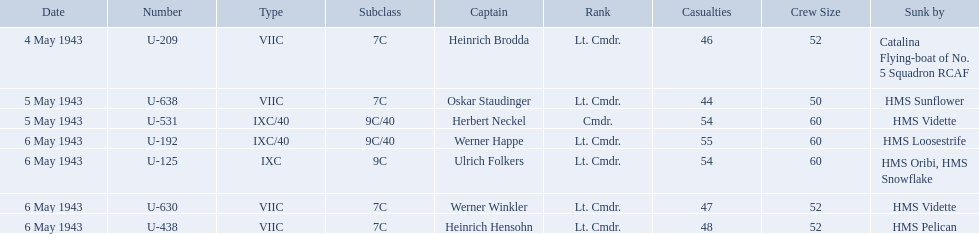Who were the captains in the ons 5 convoy? Heinrich Brodda, Oskar Staudinger, Herbert Neckel, Werner Happe, Ulrich Folkers, Werner Winkler, Heinrich Hensohn. Which ones lost their u-boat on may 5? Oskar Staudinger, Herbert Neckel. Of those, which one is not oskar staudinger? Herbert Neckel. What is the list of ships under sunk by? Catalina Flying-boat of No. 5 Squadron RCAF, HMS Sunflower, HMS Vidette, HMS Loosestrife, HMS Oribi, HMS Snowflake, HMS Vidette, HMS Pelican. Which captains did hms pelican sink? Heinrich Hensohn. Which were the names of the sinkers of the convoys? Catalina Flying-boat of No. 5 Squadron RCAF, HMS Sunflower, HMS Vidette, HMS Loosestrife, HMS Oribi, HMS Snowflake, HMS Vidette, HMS Pelican. What captain was sunk by the hms pelican? Heinrich Hensohn. 